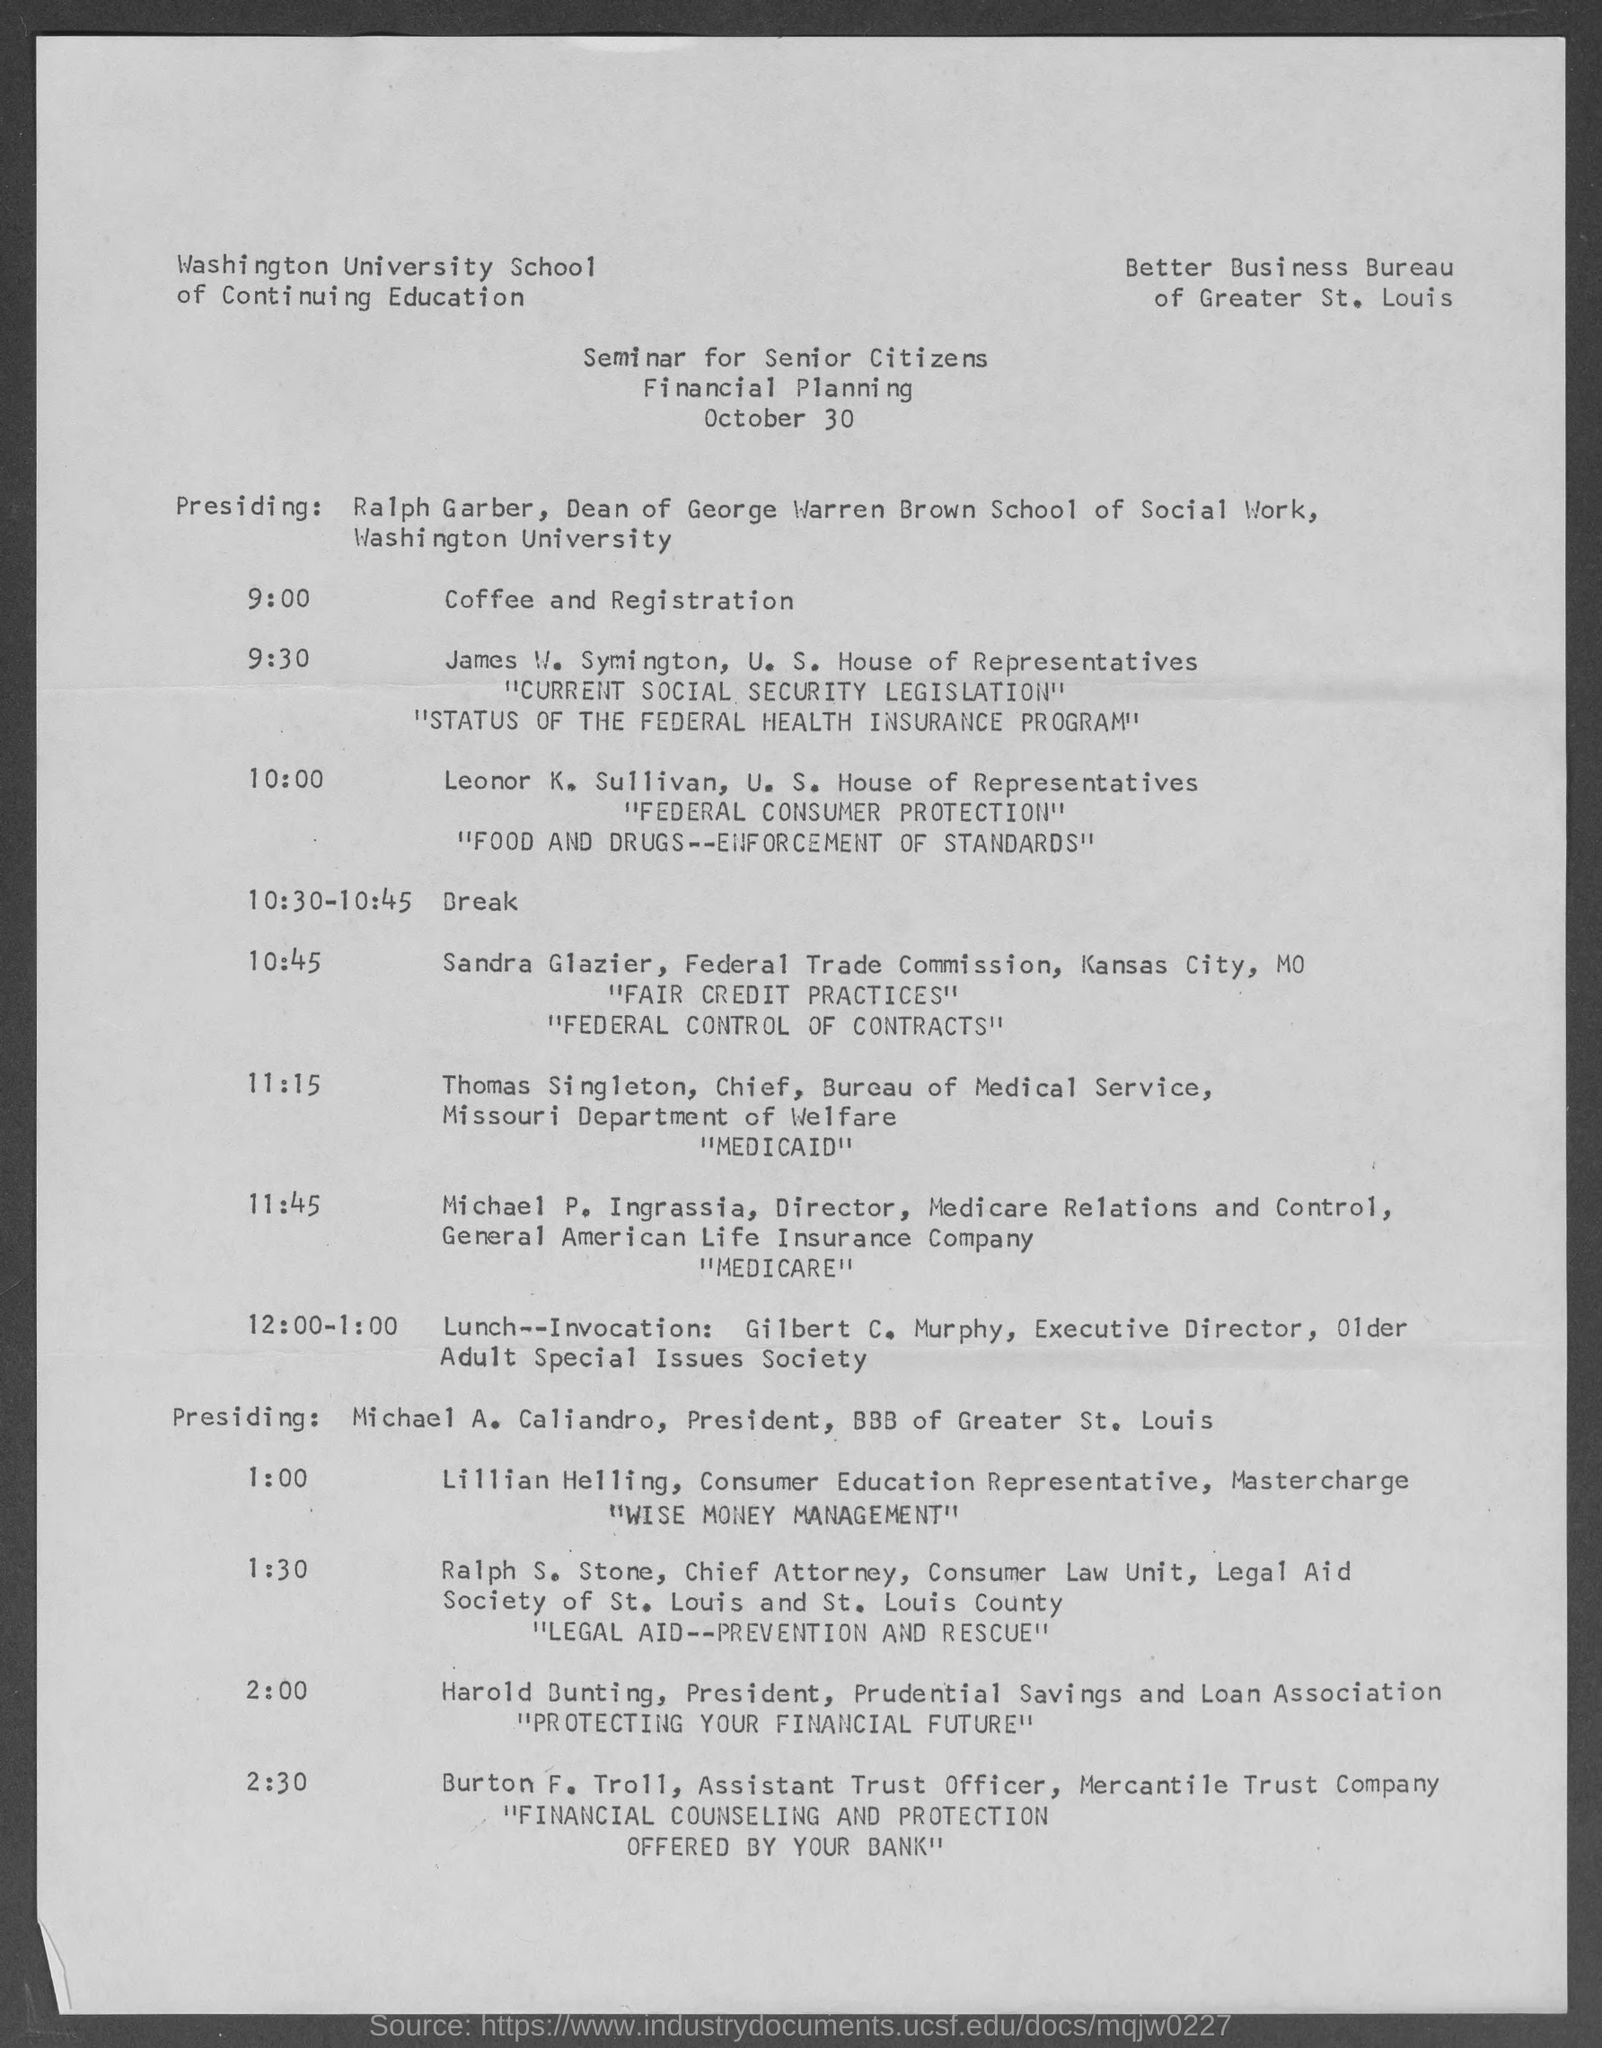What is the date on the document?
Your answer should be compact. October 30. When is the Coffee and Registration?
Ensure brevity in your answer.  9:00. 